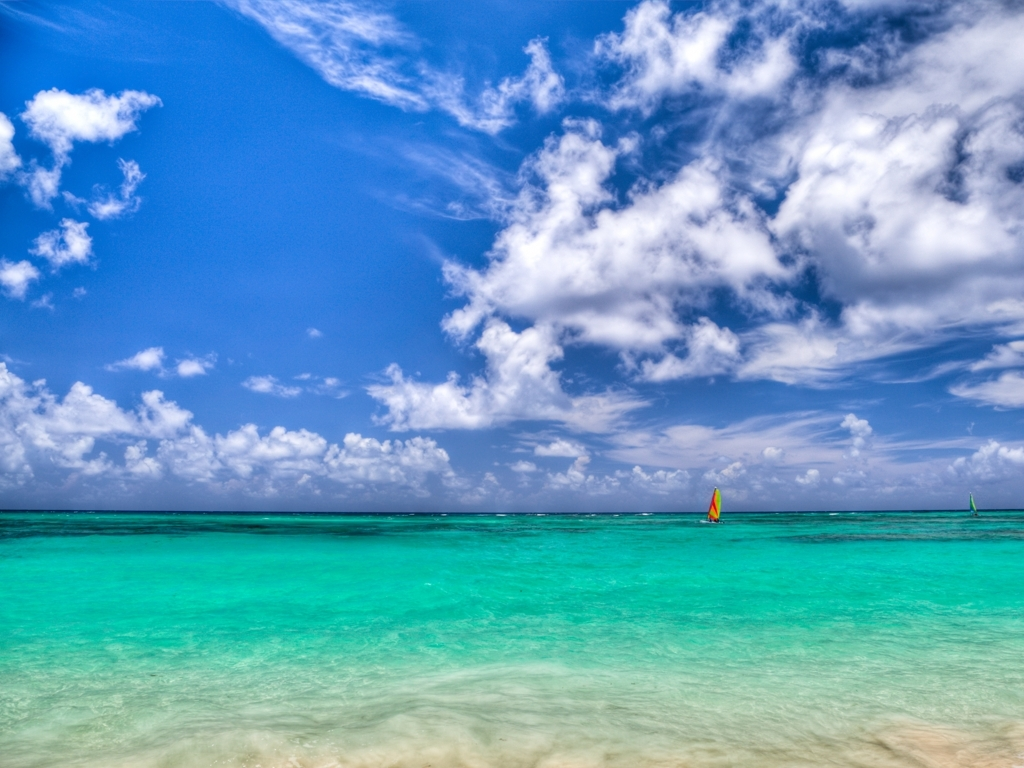Can you describe the weather conditions in this image? The weather appears to be ideal for a day at the beach, with clear skies and just a few scattered clouds adding texture to the expansive blue above. The sunlight sparkles on the turquoise waters, suggesting it's a sunny and pleasant day. What activities might be enjoyable in this setting? Given the calm sea and gentle breezes indicated by the sails on the horizon, sailing is certainly a delightful option. The clear waters would also be perfect for swimming, snorkeling to explore marine life, or simply relaxing on the pristine sands. 